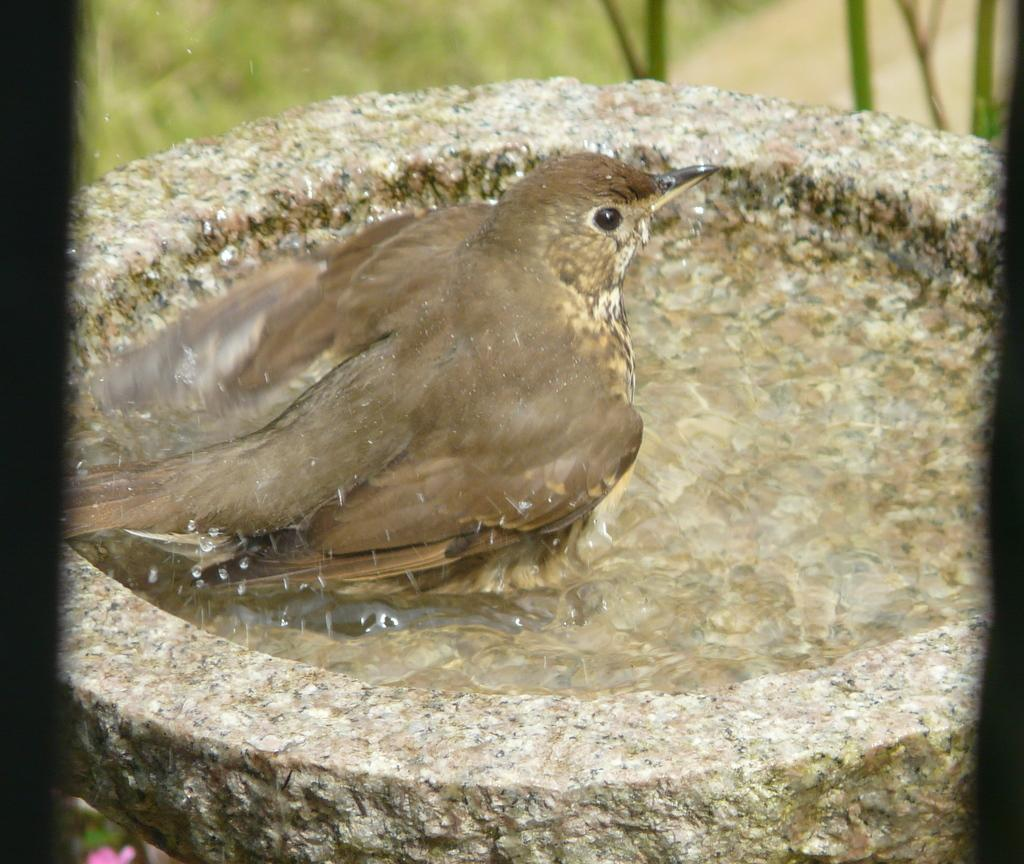What is the main object in the image? There is a stone in the image. What else can be seen in the image besides the stone? There is water visible in the image, as well as a bird. Can you describe the bird in the image? The bird has brown, cream, and black colors. How would you describe the background of the image? The background of the image is blurry. What type of whip is the bird holding in the image? There is no whip present in the image. 